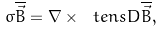<formula> <loc_0><loc_0><loc_500><loc_500>\sigma \overline { \vec { B } } = \nabla \times \ t e n s { D } \overline { \vec { B } } ,</formula> 